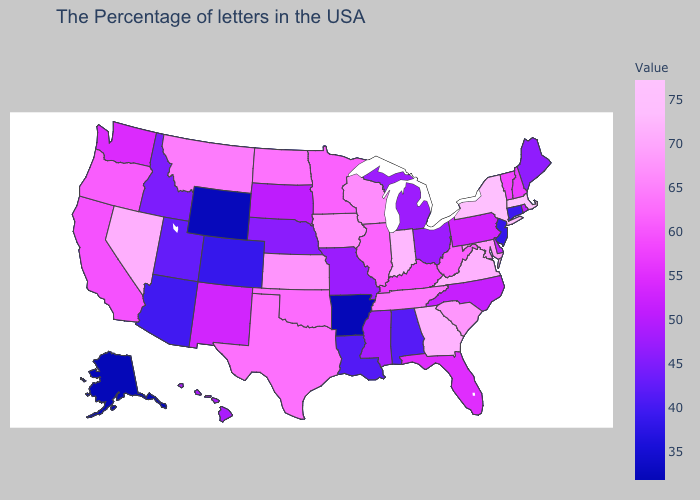Among the states that border New Mexico , which have the lowest value?
Give a very brief answer. Colorado. Does New York have a higher value than Utah?
Keep it brief. Yes. Does Rhode Island have a higher value than Idaho?
Short answer required. Yes. Among the states that border Colorado , does Wyoming have the highest value?
Short answer required. No. Among the states that border Maryland , which have the lowest value?
Write a very short answer. Delaware. Which states have the lowest value in the Northeast?
Give a very brief answer. New Jersey. 